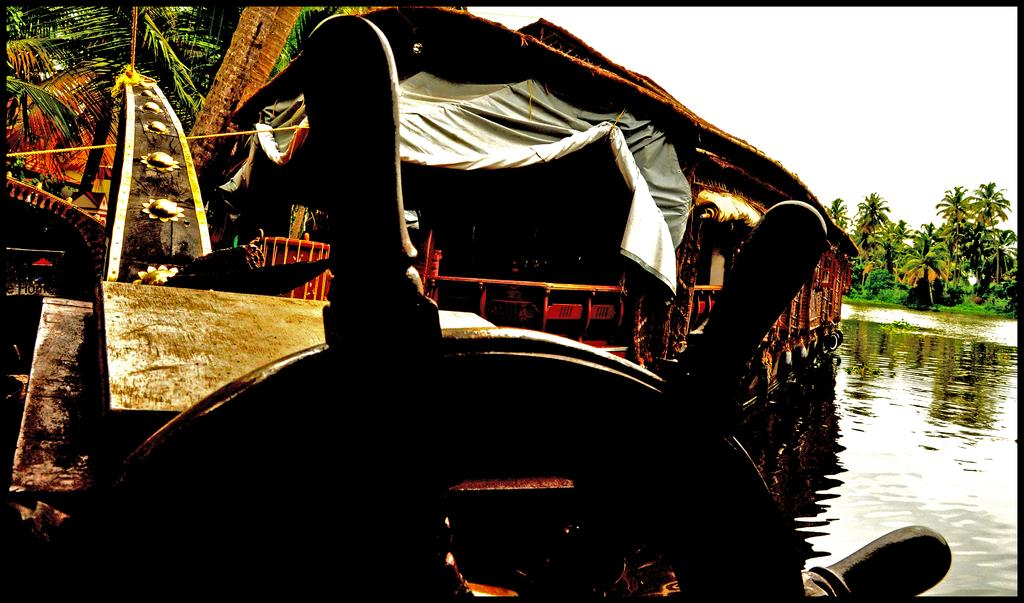What is the main feature of the image? The main feature of the image is water. What is on the surface of the water? There are ships on the surface of the water. What color are the ships? The ships are brown in color. What can be seen in the background of the image? There are trees and the sky visible in the background of the image. What color are the trees? The trees are green in color. How much ink is required to draw the ships in the image? There is no ink present in the image, as it is a photograph. The ships are real and not drawn. 